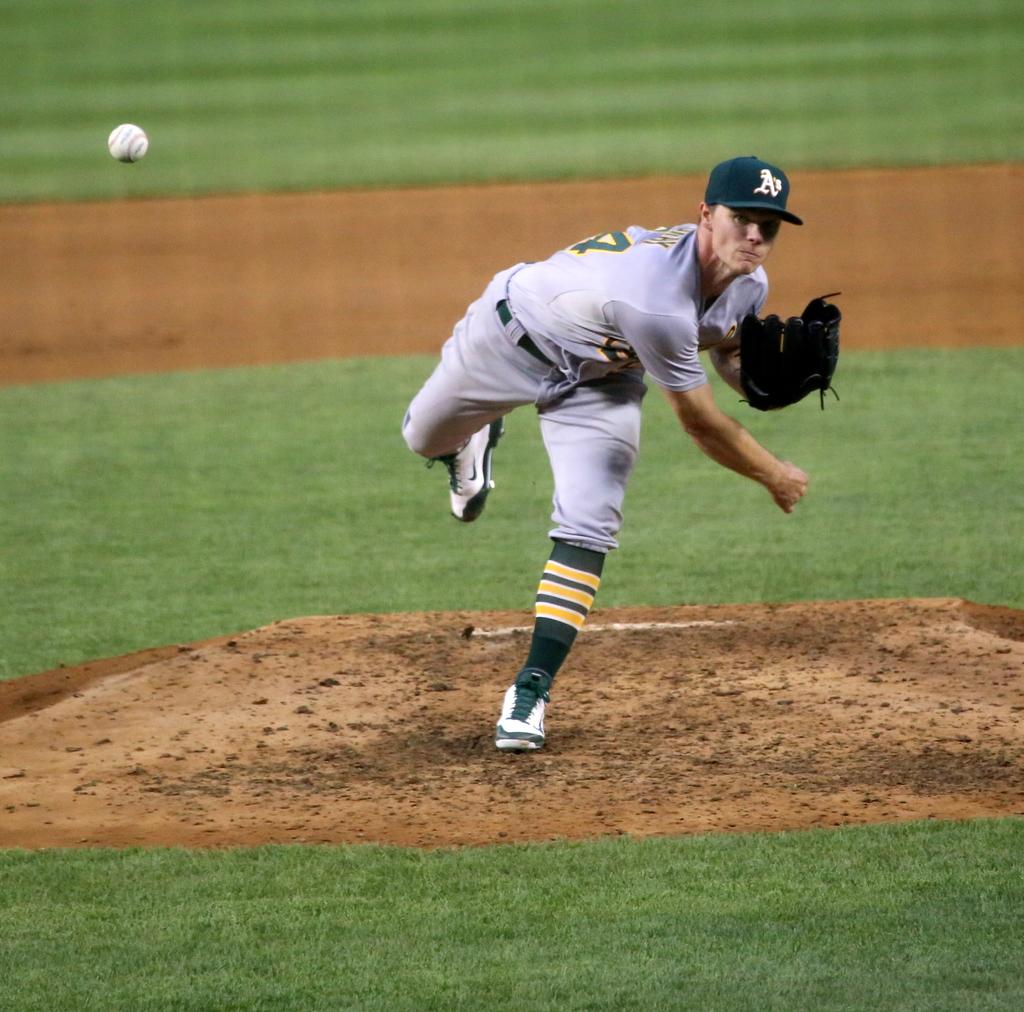What letter is on the player's hat?
Provide a short and direct response. A. What number can be seen on the jersey?
Provide a succinct answer. 4. 